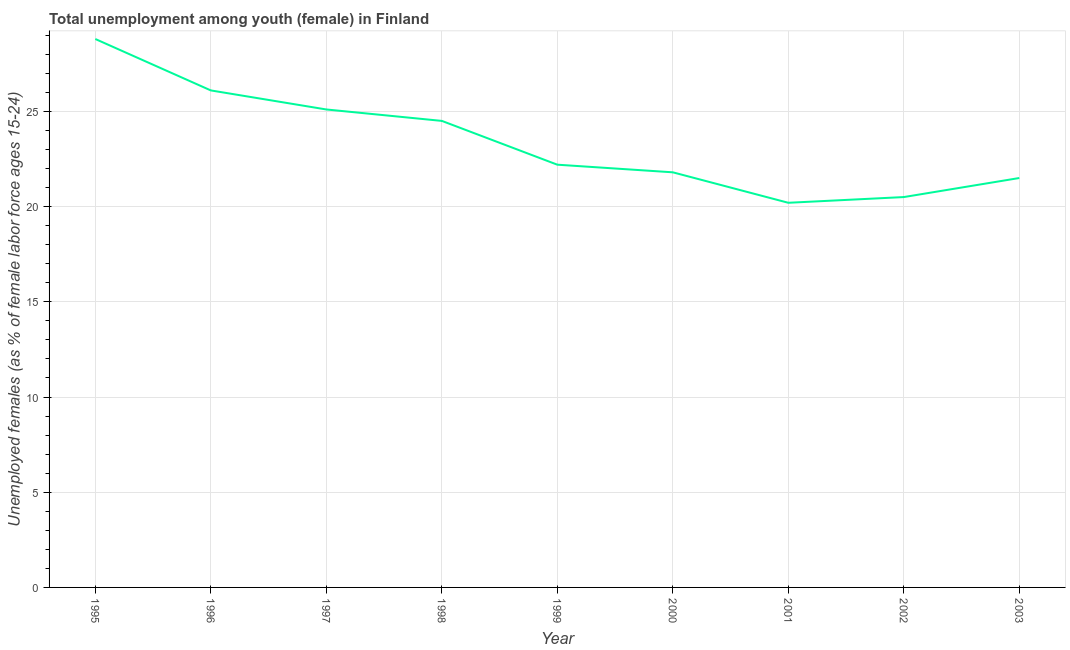What is the unemployed female youth population in 1999?
Offer a terse response. 22.2. Across all years, what is the maximum unemployed female youth population?
Your answer should be very brief. 28.8. Across all years, what is the minimum unemployed female youth population?
Your answer should be very brief. 20.2. In which year was the unemployed female youth population minimum?
Provide a succinct answer. 2001. What is the sum of the unemployed female youth population?
Make the answer very short. 210.7. What is the difference between the unemployed female youth population in 1995 and 1999?
Provide a succinct answer. 6.6. What is the average unemployed female youth population per year?
Make the answer very short. 23.41. What is the median unemployed female youth population?
Your answer should be compact. 22.2. In how many years, is the unemployed female youth population greater than 26 %?
Your answer should be very brief. 2. What is the ratio of the unemployed female youth population in 1996 to that in 2002?
Provide a short and direct response. 1.27. What is the difference between the highest and the second highest unemployed female youth population?
Provide a succinct answer. 2.7. What is the difference between the highest and the lowest unemployed female youth population?
Provide a succinct answer. 8.6. Does the unemployed female youth population monotonically increase over the years?
Give a very brief answer. No. How many years are there in the graph?
Give a very brief answer. 9. Are the values on the major ticks of Y-axis written in scientific E-notation?
Your response must be concise. No. What is the title of the graph?
Offer a terse response. Total unemployment among youth (female) in Finland. What is the label or title of the X-axis?
Your answer should be very brief. Year. What is the label or title of the Y-axis?
Offer a terse response. Unemployed females (as % of female labor force ages 15-24). What is the Unemployed females (as % of female labor force ages 15-24) of 1995?
Your response must be concise. 28.8. What is the Unemployed females (as % of female labor force ages 15-24) of 1996?
Give a very brief answer. 26.1. What is the Unemployed females (as % of female labor force ages 15-24) in 1997?
Provide a short and direct response. 25.1. What is the Unemployed females (as % of female labor force ages 15-24) of 1999?
Offer a very short reply. 22.2. What is the Unemployed females (as % of female labor force ages 15-24) of 2000?
Offer a terse response. 21.8. What is the Unemployed females (as % of female labor force ages 15-24) in 2001?
Keep it short and to the point. 20.2. What is the Unemployed females (as % of female labor force ages 15-24) in 2003?
Your answer should be compact. 21.5. What is the difference between the Unemployed females (as % of female labor force ages 15-24) in 1995 and 1997?
Ensure brevity in your answer.  3.7. What is the difference between the Unemployed females (as % of female labor force ages 15-24) in 1995 and 1998?
Offer a terse response. 4.3. What is the difference between the Unemployed females (as % of female labor force ages 15-24) in 1995 and 1999?
Ensure brevity in your answer.  6.6. What is the difference between the Unemployed females (as % of female labor force ages 15-24) in 1995 and 2001?
Offer a very short reply. 8.6. What is the difference between the Unemployed females (as % of female labor force ages 15-24) in 1995 and 2003?
Give a very brief answer. 7.3. What is the difference between the Unemployed females (as % of female labor force ages 15-24) in 1996 and 1999?
Your answer should be very brief. 3.9. What is the difference between the Unemployed females (as % of female labor force ages 15-24) in 1996 and 2001?
Your answer should be compact. 5.9. What is the difference between the Unemployed females (as % of female labor force ages 15-24) in 1997 and 2002?
Make the answer very short. 4.6. What is the difference between the Unemployed females (as % of female labor force ages 15-24) in 1998 and 2000?
Your answer should be compact. 2.7. What is the difference between the Unemployed females (as % of female labor force ages 15-24) in 1998 and 2002?
Ensure brevity in your answer.  4. What is the difference between the Unemployed females (as % of female labor force ages 15-24) in 1999 and 2000?
Your answer should be compact. 0.4. What is the difference between the Unemployed females (as % of female labor force ages 15-24) in 1999 and 2001?
Your answer should be compact. 2. What is the difference between the Unemployed females (as % of female labor force ages 15-24) in 1999 and 2002?
Give a very brief answer. 1.7. What is the difference between the Unemployed females (as % of female labor force ages 15-24) in 1999 and 2003?
Offer a terse response. 0.7. What is the difference between the Unemployed females (as % of female labor force ages 15-24) in 2000 and 2001?
Offer a very short reply. 1.6. What is the difference between the Unemployed females (as % of female labor force ages 15-24) in 2000 and 2002?
Offer a terse response. 1.3. What is the difference between the Unemployed females (as % of female labor force ages 15-24) in 2000 and 2003?
Ensure brevity in your answer.  0.3. What is the difference between the Unemployed females (as % of female labor force ages 15-24) in 2002 and 2003?
Your answer should be very brief. -1. What is the ratio of the Unemployed females (as % of female labor force ages 15-24) in 1995 to that in 1996?
Provide a succinct answer. 1.1. What is the ratio of the Unemployed females (as % of female labor force ages 15-24) in 1995 to that in 1997?
Offer a very short reply. 1.15. What is the ratio of the Unemployed females (as % of female labor force ages 15-24) in 1995 to that in 1998?
Your answer should be compact. 1.18. What is the ratio of the Unemployed females (as % of female labor force ages 15-24) in 1995 to that in 1999?
Provide a short and direct response. 1.3. What is the ratio of the Unemployed females (as % of female labor force ages 15-24) in 1995 to that in 2000?
Make the answer very short. 1.32. What is the ratio of the Unemployed females (as % of female labor force ages 15-24) in 1995 to that in 2001?
Provide a short and direct response. 1.43. What is the ratio of the Unemployed females (as % of female labor force ages 15-24) in 1995 to that in 2002?
Your answer should be very brief. 1.41. What is the ratio of the Unemployed females (as % of female labor force ages 15-24) in 1995 to that in 2003?
Your answer should be very brief. 1.34. What is the ratio of the Unemployed females (as % of female labor force ages 15-24) in 1996 to that in 1998?
Ensure brevity in your answer.  1.06. What is the ratio of the Unemployed females (as % of female labor force ages 15-24) in 1996 to that in 1999?
Your answer should be compact. 1.18. What is the ratio of the Unemployed females (as % of female labor force ages 15-24) in 1996 to that in 2000?
Your answer should be very brief. 1.2. What is the ratio of the Unemployed females (as % of female labor force ages 15-24) in 1996 to that in 2001?
Your response must be concise. 1.29. What is the ratio of the Unemployed females (as % of female labor force ages 15-24) in 1996 to that in 2002?
Give a very brief answer. 1.27. What is the ratio of the Unemployed females (as % of female labor force ages 15-24) in 1996 to that in 2003?
Offer a very short reply. 1.21. What is the ratio of the Unemployed females (as % of female labor force ages 15-24) in 1997 to that in 1999?
Your answer should be compact. 1.13. What is the ratio of the Unemployed females (as % of female labor force ages 15-24) in 1997 to that in 2000?
Provide a succinct answer. 1.15. What is the ratio of the Unemployed females (as % of female labor force ages 15-24) in 1997 to that in 2001?
Give a very brief answer. 1.24. What is the ratio of the Unemployed females (as % of female labor force ages 15-24) in 1997 to that in 2002?
Your answer should be compact. 1.22. What is the ratio of the Unemployed females (as % of female labor force ages 15-24) in 1997 to that in 2003?
Ensure brevity in your answer.  1.17. What is the ratio of the Unemployed females (as % of female labor force ages 15-24) in 1998 to that in 1999?
Make the answer very short. 1.1. What is the ratio of the Unemployed females (as % of female labor force ages 15-24) in 1998 to that in 2000?
Your answer should be very brief. 1.12. What is the ratio of the Unemployed females (as % of female labor force ages 15-24) in 1998 to that in 2001?
Provide a succinct answer. 1.21. What is the ratio of the Unemployed females (as % of female labor force ages 15-24) in 1998 to that in 2002?
Your response must be concise. 1.2. What is the ratio of the Unemployed females (as % of female labor force ages 15-24) in 1998 to that in 2003?
Ensure brevity in your answer.  1.14. What is the ratio of the Unemployed females (as % of female labor force ages 15-24) in 1999 to that in 2001?
Offer a very short reply. 1.1. What is the ratio of the Unemployed females (as % of female labor force ages 15-24) in 1999 to that in 2002?
Your answer should be compact. 1.08. What is the ratio of the Unemployed females (as % of female labor force ages 15-24) in 1999 to that in 2003?
Ensure brevity in your answer.  1.03. What is the ratio of the Unemployed females (as % of female labor force ages 15-24) in 2000 to that in 2001?
Offer a terse response. 1.08. What is the ratio of the Unemployed females (as % of female labor force ages 15-24) in 2000 to that in 2002?
Provide a short and direct response. 1.06. What is the ratio of the Unemployed females (as % of female labor force ages 15-24) in 2001 to that in 2002?
Make the answer very short. 0.98. What is the ratio of the Unemployed females (as % of female labor force ages 15-24) in 2001 to that in 2003?
Your answer should be compact. 0.94. What is the ratio of the Unemployed females (as % of female labor force ages 15-24) in 2002 to that in 2003?
Your response must be concise. 0.95. 